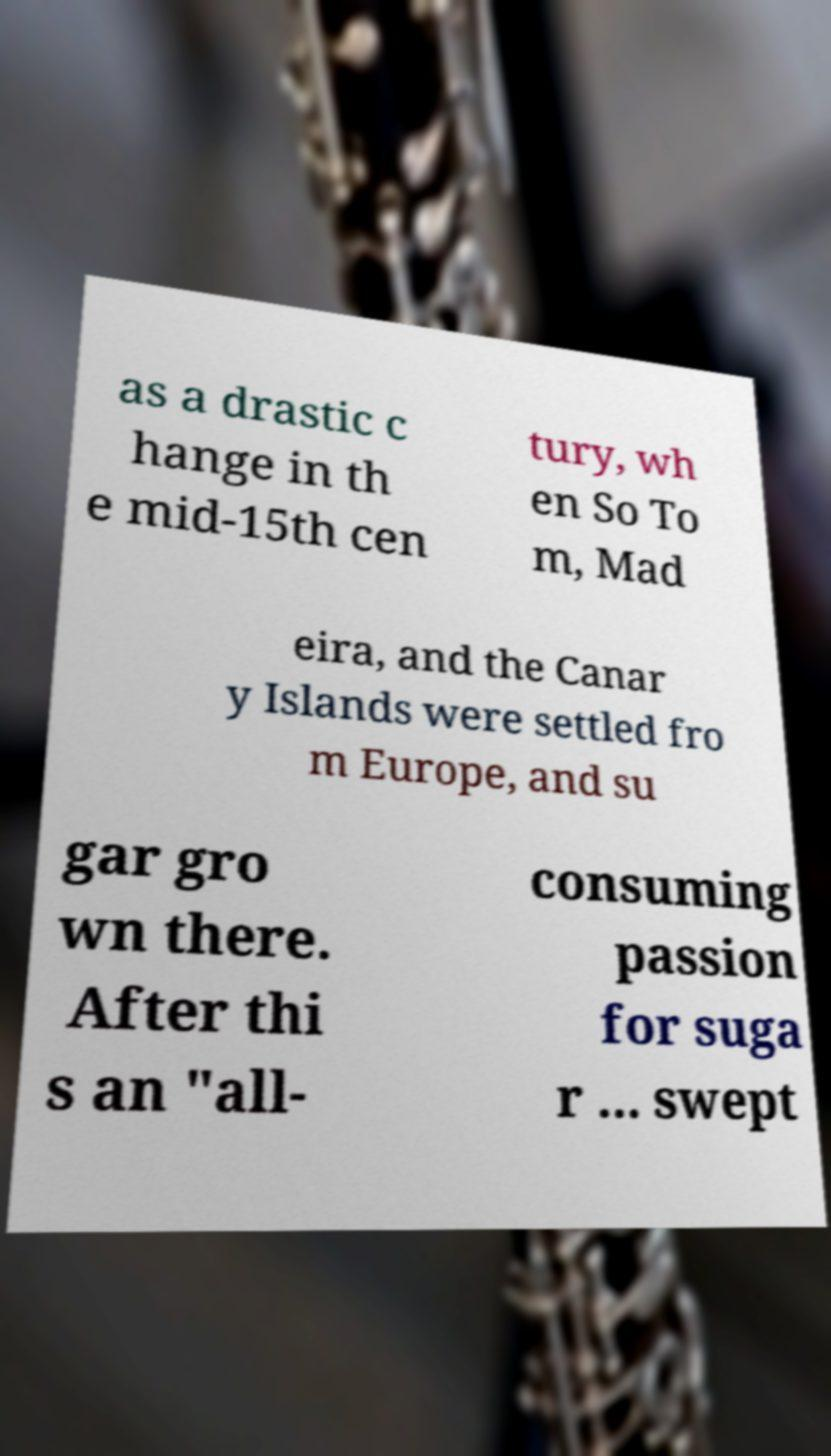I need the written content from this picture converted into text. Can you do that? as a drastic c hange in th e mid-15th cen tury, wh en So To m, Mad eira, and the Canar y Islands were settled fro m Europe, and su gar gro wn there. After thi s an "all- consuming passion for suga r ... swept 